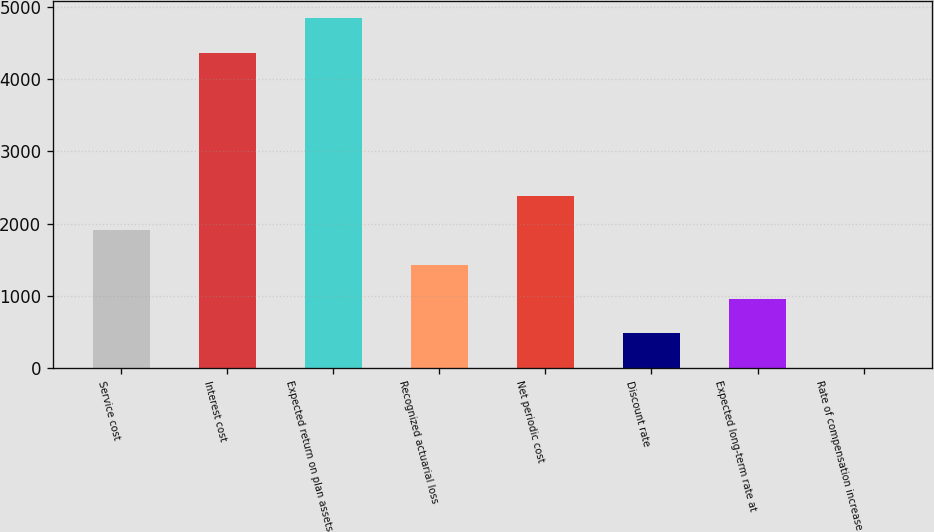<chart> <loc_0><loc_0><loc_500><loc_500><bar_chart><fcel>Service cost<fcel>Interest cost<fcel>Expected return on plan assets<fcel>Recognized actuarial loss<fcel>Net periodic cost<fcel>Discount rate<fcel>Expected long-term rate at<fcel>Rate of compensation increase<nl><fcel>1911.2<fcel>4365<fcel>4841.8<fcel>1434.4<fcel>2388<fcel>480.8<fcel>957.6<fcel>4<nl></chart> 